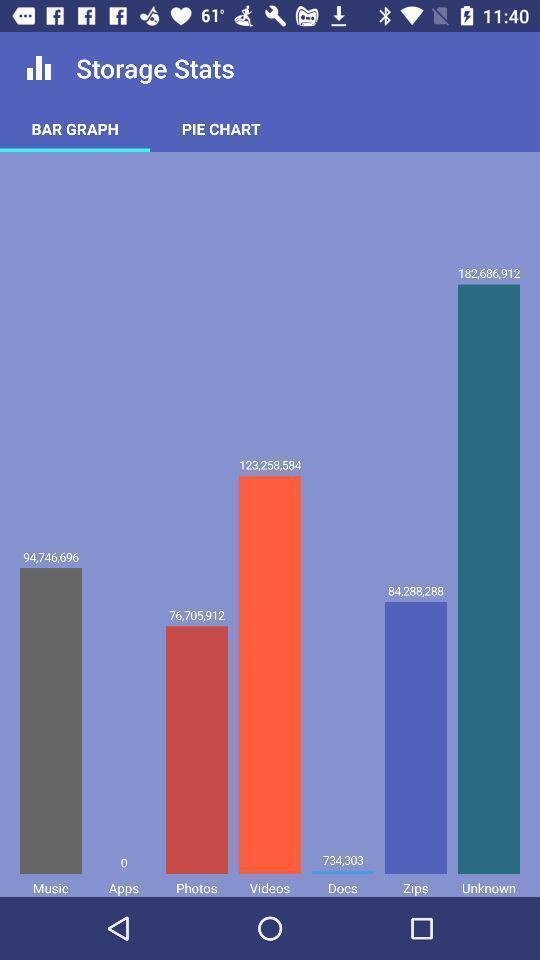Explain what's happening in this screen capture. Page showing bar graph. 